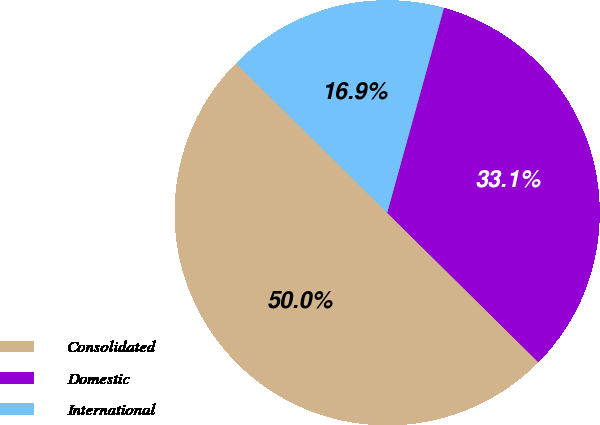<chart> <loc_0><loc_0><loc_500><loc_500><pie_chart><fcel>Consolidated<fcel>Domestic<fcel>International<nl><fcel>50.0%<fcel>33.11%<fcel>16.89%<nl></chart> 